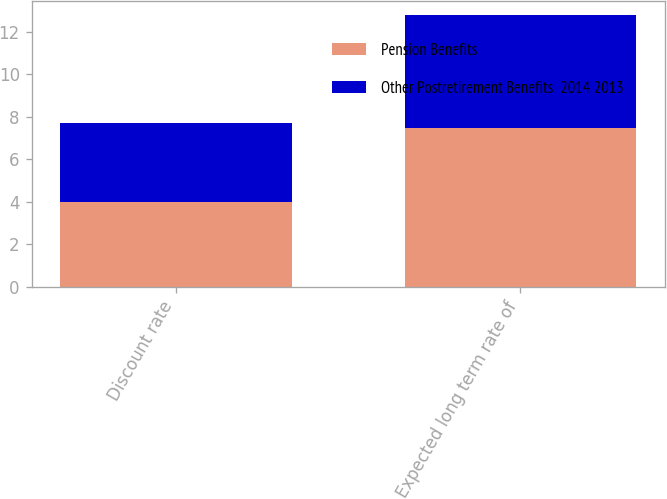<chart> <loc_0><loc_0><loc_500><loc_500><stacked_bar_chart><ecel><fcel>Discount rate<fcel>Expected long term rate of<nl><fcel>Pension Benefits<fcel>4<fcel>7.5<nl><fcel>Other Postretirement Benefits  2014 2013<fcel>3.7<fcel>5.3<nl></chart> 